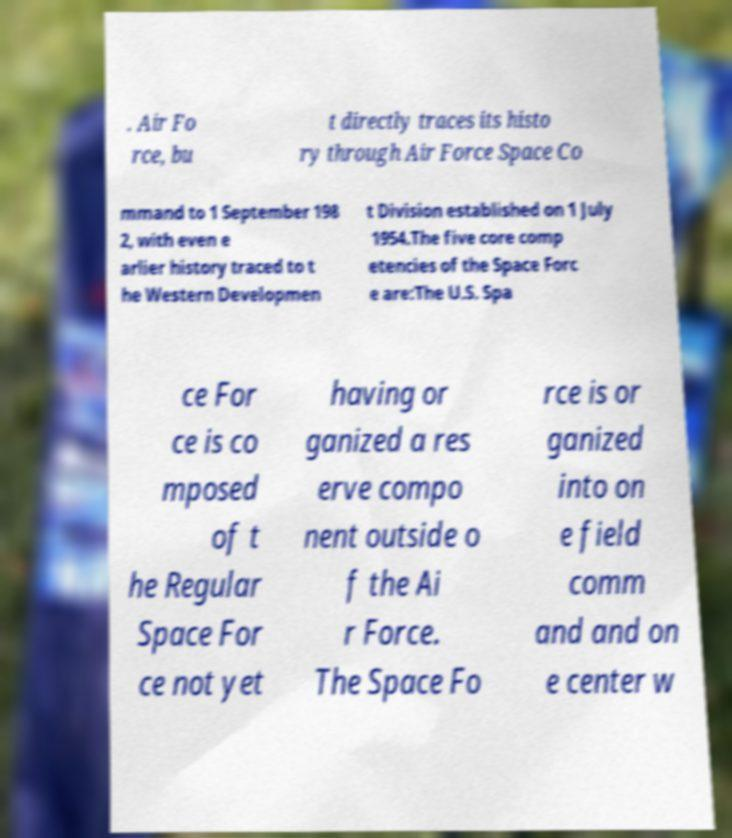What messages or text are displayed in this image? I need them in a readable, typed format. . Air Fo rce, bu t directly traces its histo ry through Air Force Space Co mmand to 1 September 198 2, with even e arlier history traced to t he Western Developmen t Division established on 1 July 1954.The five core comp etencies of the Space Forc e are:The U.S. Spa ce For ce is co mposed of t he Regular Space For ce not yet having or ganized a res erve compo nent outside o f the Ai r Force. The Space Fo rce is or ganized into on e field comm and and on e center w 